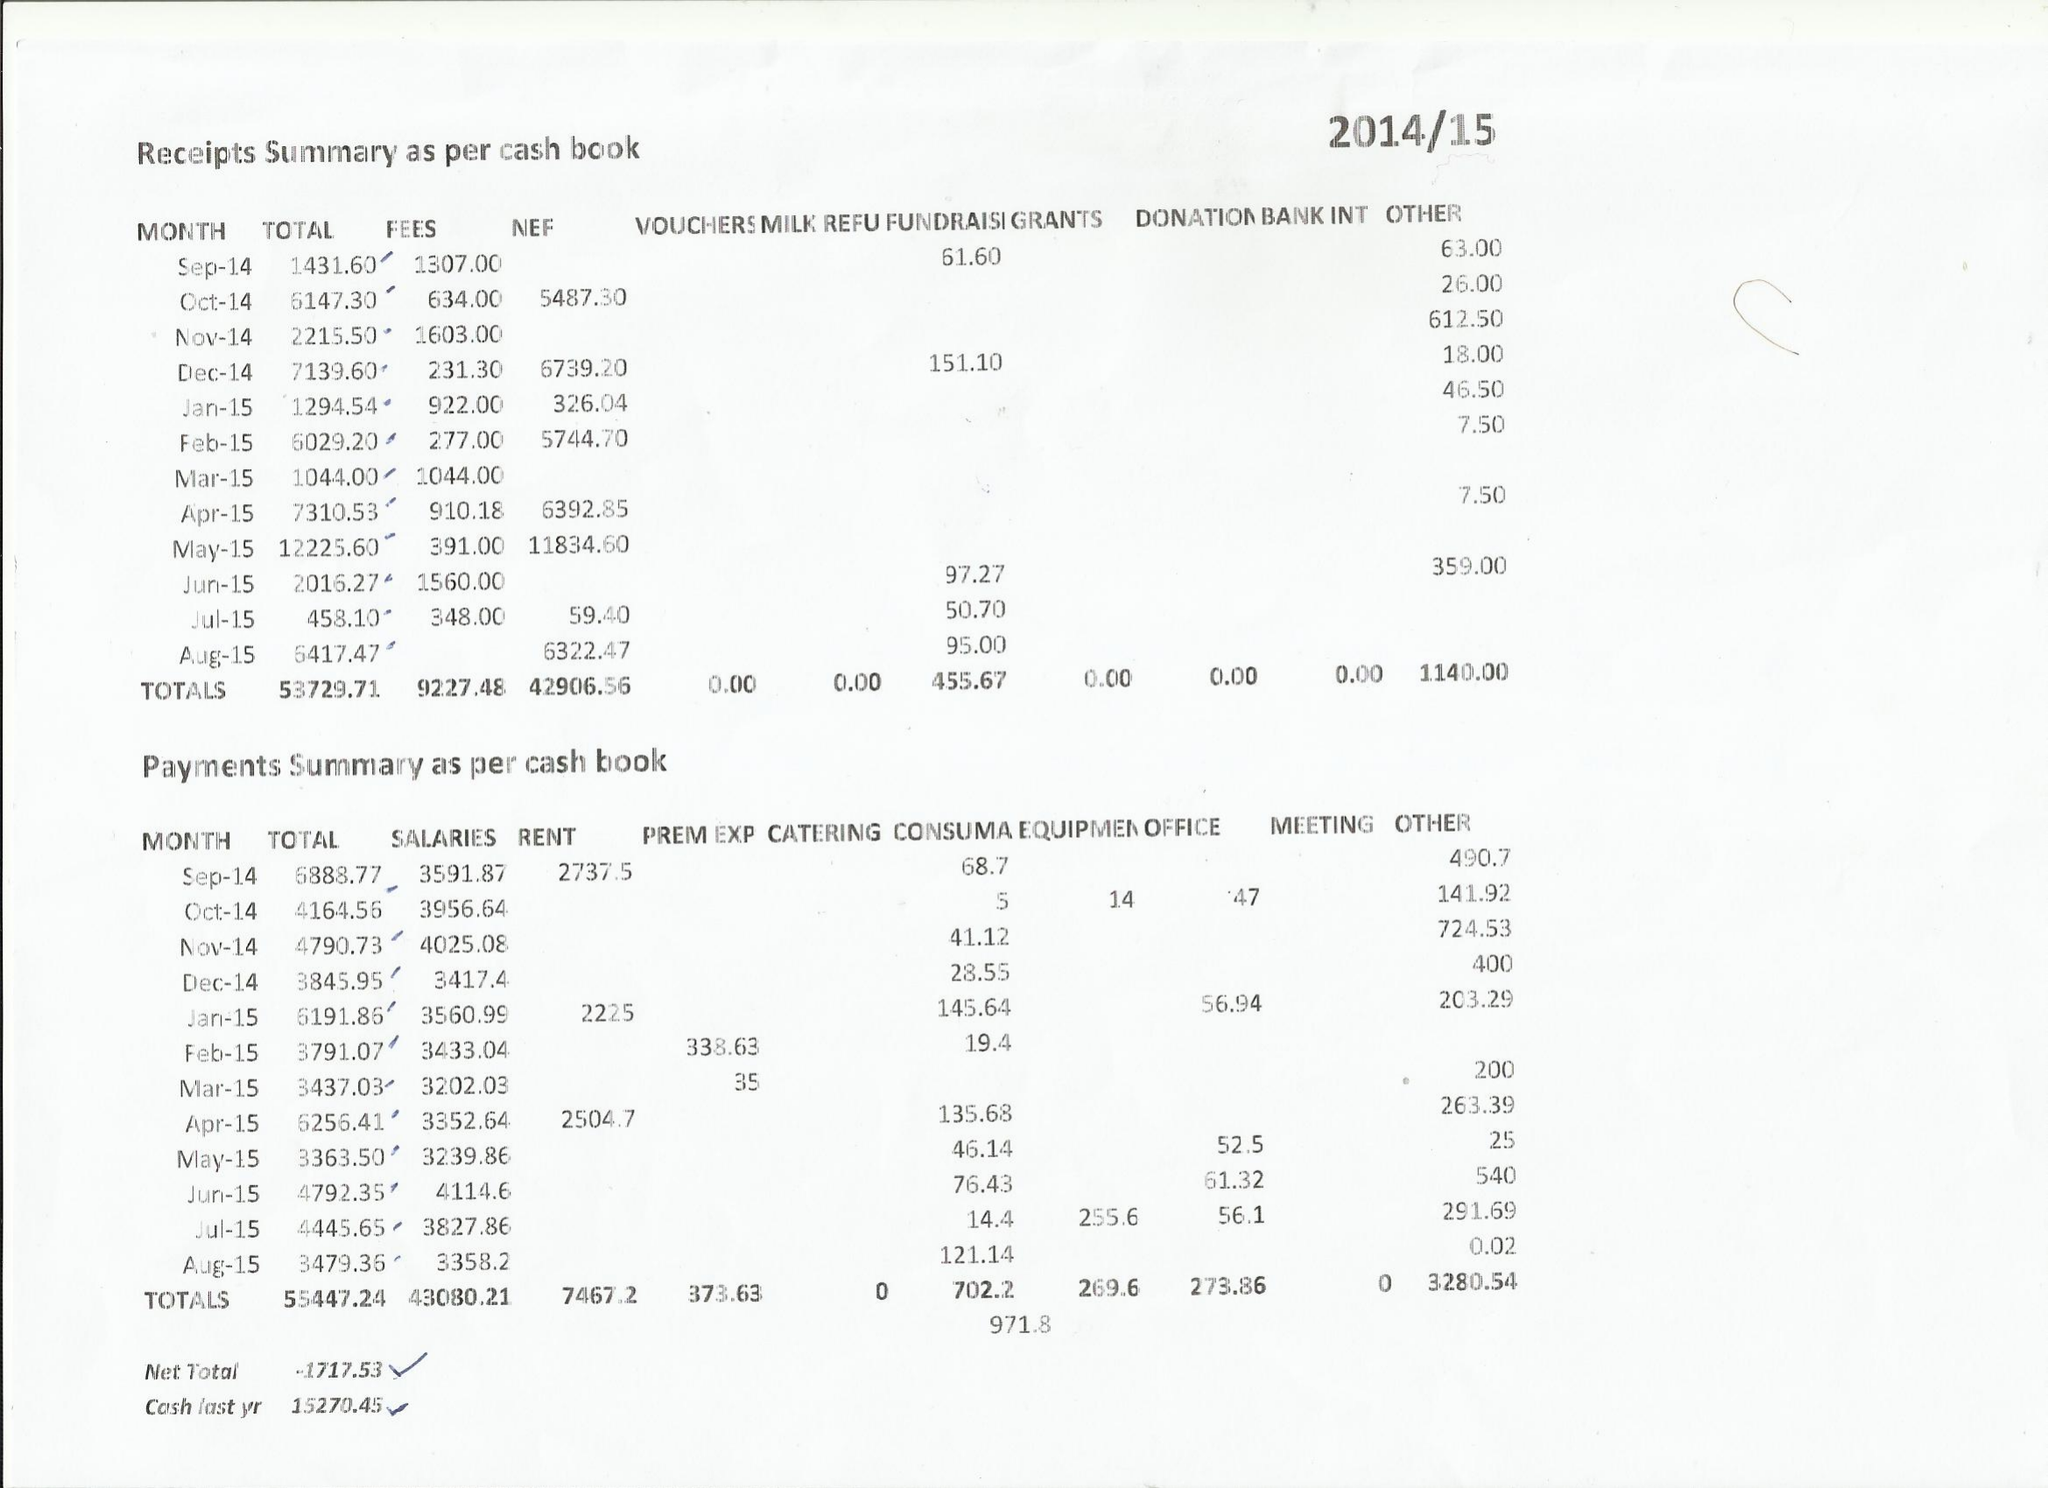What is the value for the charity_number?
Answer the question using a single word or phrase. 1026317 